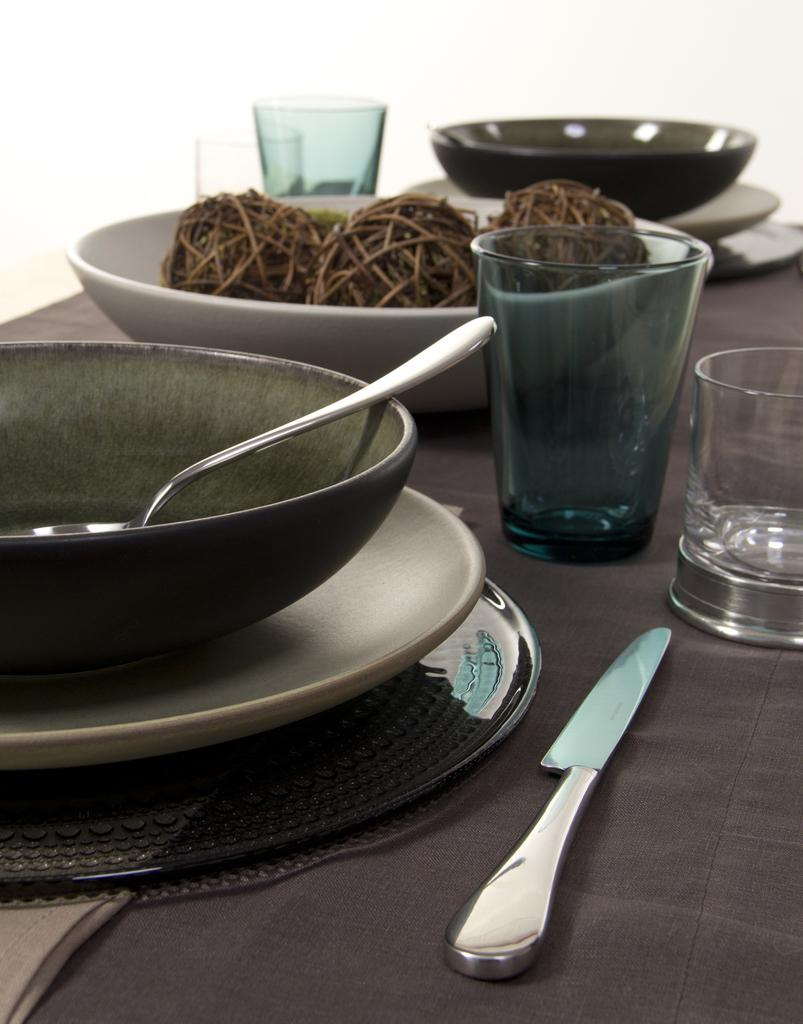What piece of furniture is present in the image? There is a table in the image. What items are placed on the table? There are plates, bowls, spoons, glasses, and knives on the table. How many types of tableware can be seen in the image? There are five types of tableware visible: plates, bowls, spoons, glasses, and knives. Can you see any steam rising from the plates in the image? There is no steam visible in the image; the plates are not shown with any food or heat source. 